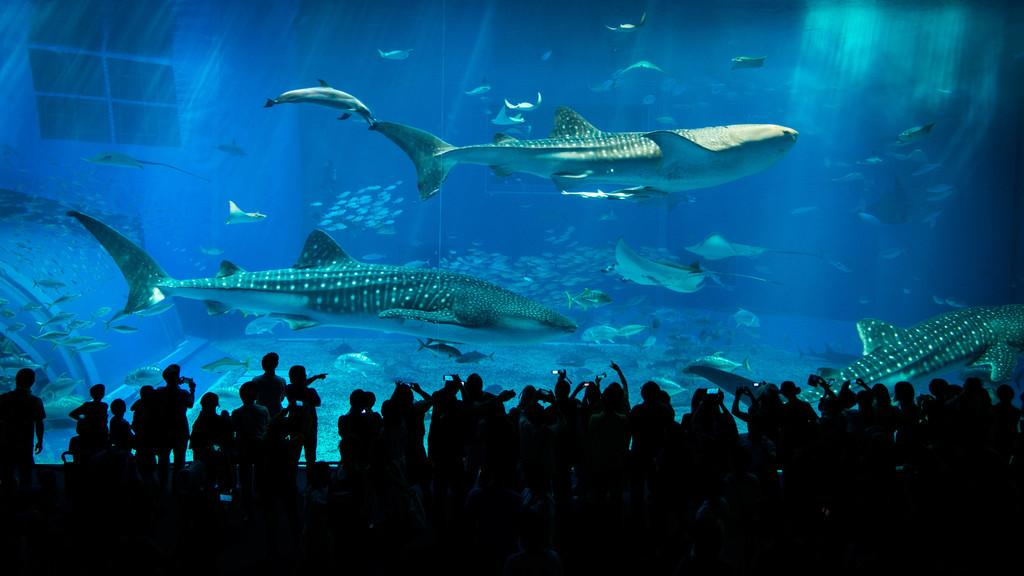What is located at the bottom of the image? There is a group of people at the people at the bottom of the image. What is the main feature in the center of the image? There is an aquarium in the center of the image. What can be found inside the aquarium? The aquarium contains fishes. What can be seen in the background of the image? There is a window visible in the background of the image. What type of lunch is being served in the image? There is no lunch visible in the image. Can you spot a bear in the image? There is no bear present in the image. 